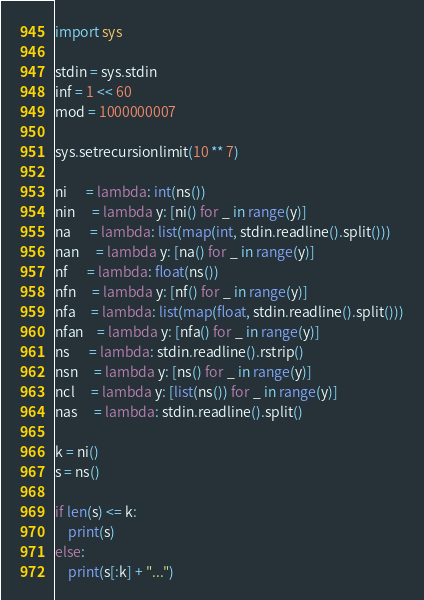Convert code to text. <code><loc_0><loc_0><loc_500><loc_500><_Python_>import sys

stdin = sys.stdin
inf = 1 << 60
mod = 1000000007

sys.setrecursionlimit(10 ** 7)

ni      = lambda: int(ns())
nin     = lambda y: [ni() for _ in range(y)]
na      = lambda: list(map(int, stdin.readline().split()))
nan     = lambda y: [na() for _ in range(y)]
nf      = lambda: float(ns())
nfn     = lambda y: [nf() for _ in range(y)]
nfa     = lambda: list(map(float, stdin.readline().split()))
nfan    = lambda y: [nfa() for _ in range(y)]
ns      = lambda: stdin.readline().rstrip()
nsn     = lambda y: [ns() for _ in range(y)]
ncl     = lambda y: [list(ns()) for _ in range(y)]
nas     = lambda: stdin.readline().split()

k = ni()
s = ns()

if len(s) <= k:
    print(s)
else:
    print(s[:k] + "...")</code> 